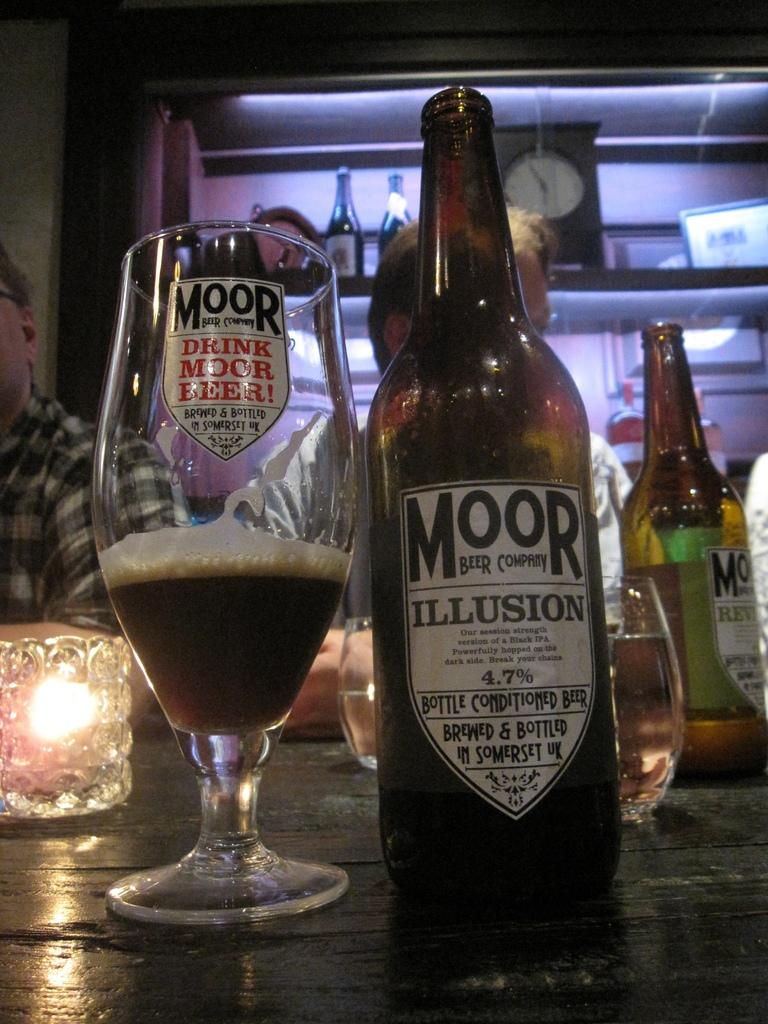<image>
Provide a brief description of the given image. Bottle with a white label that says MOOR ILLUSION on it. 